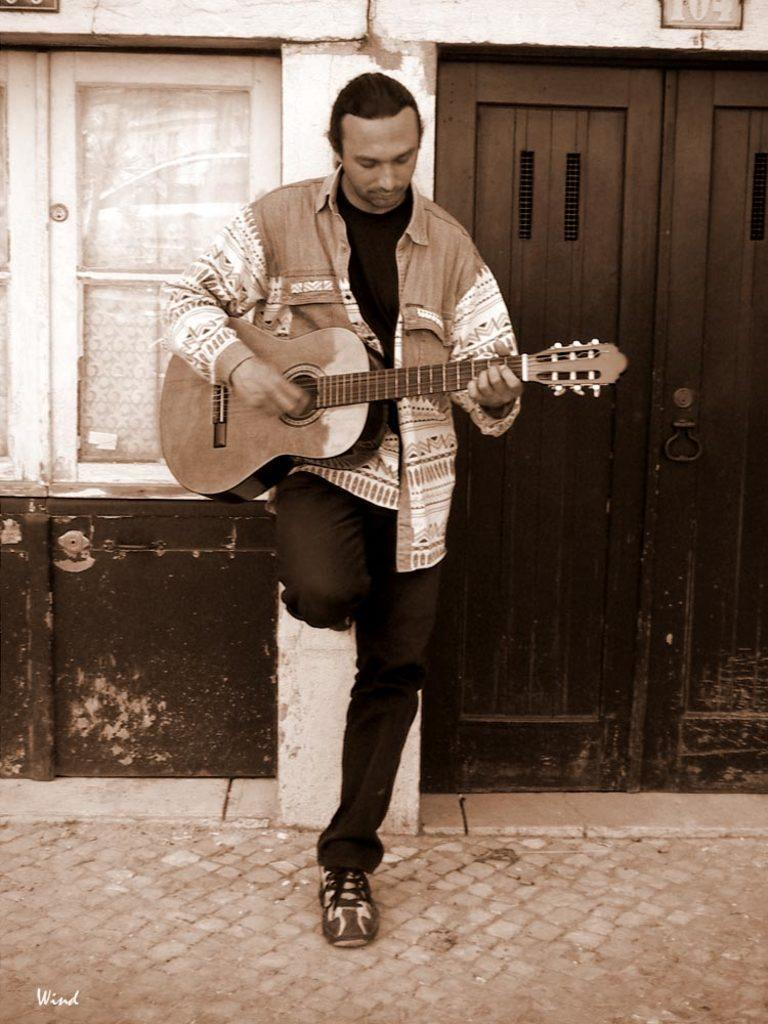What is the person in the image wearing? The person is wearing a shirt. What activity is the person engaged in? The person is playing a guitar. What can be seen in the background of the image? There is a building with a window and a door in the background. What type of industry can be seen in the background of the image? There is no industry visible in the background of the image; it features a building with a window and a door. What type of dress is the person wearing in the image? The person is wearing a shirt, not a dress. 